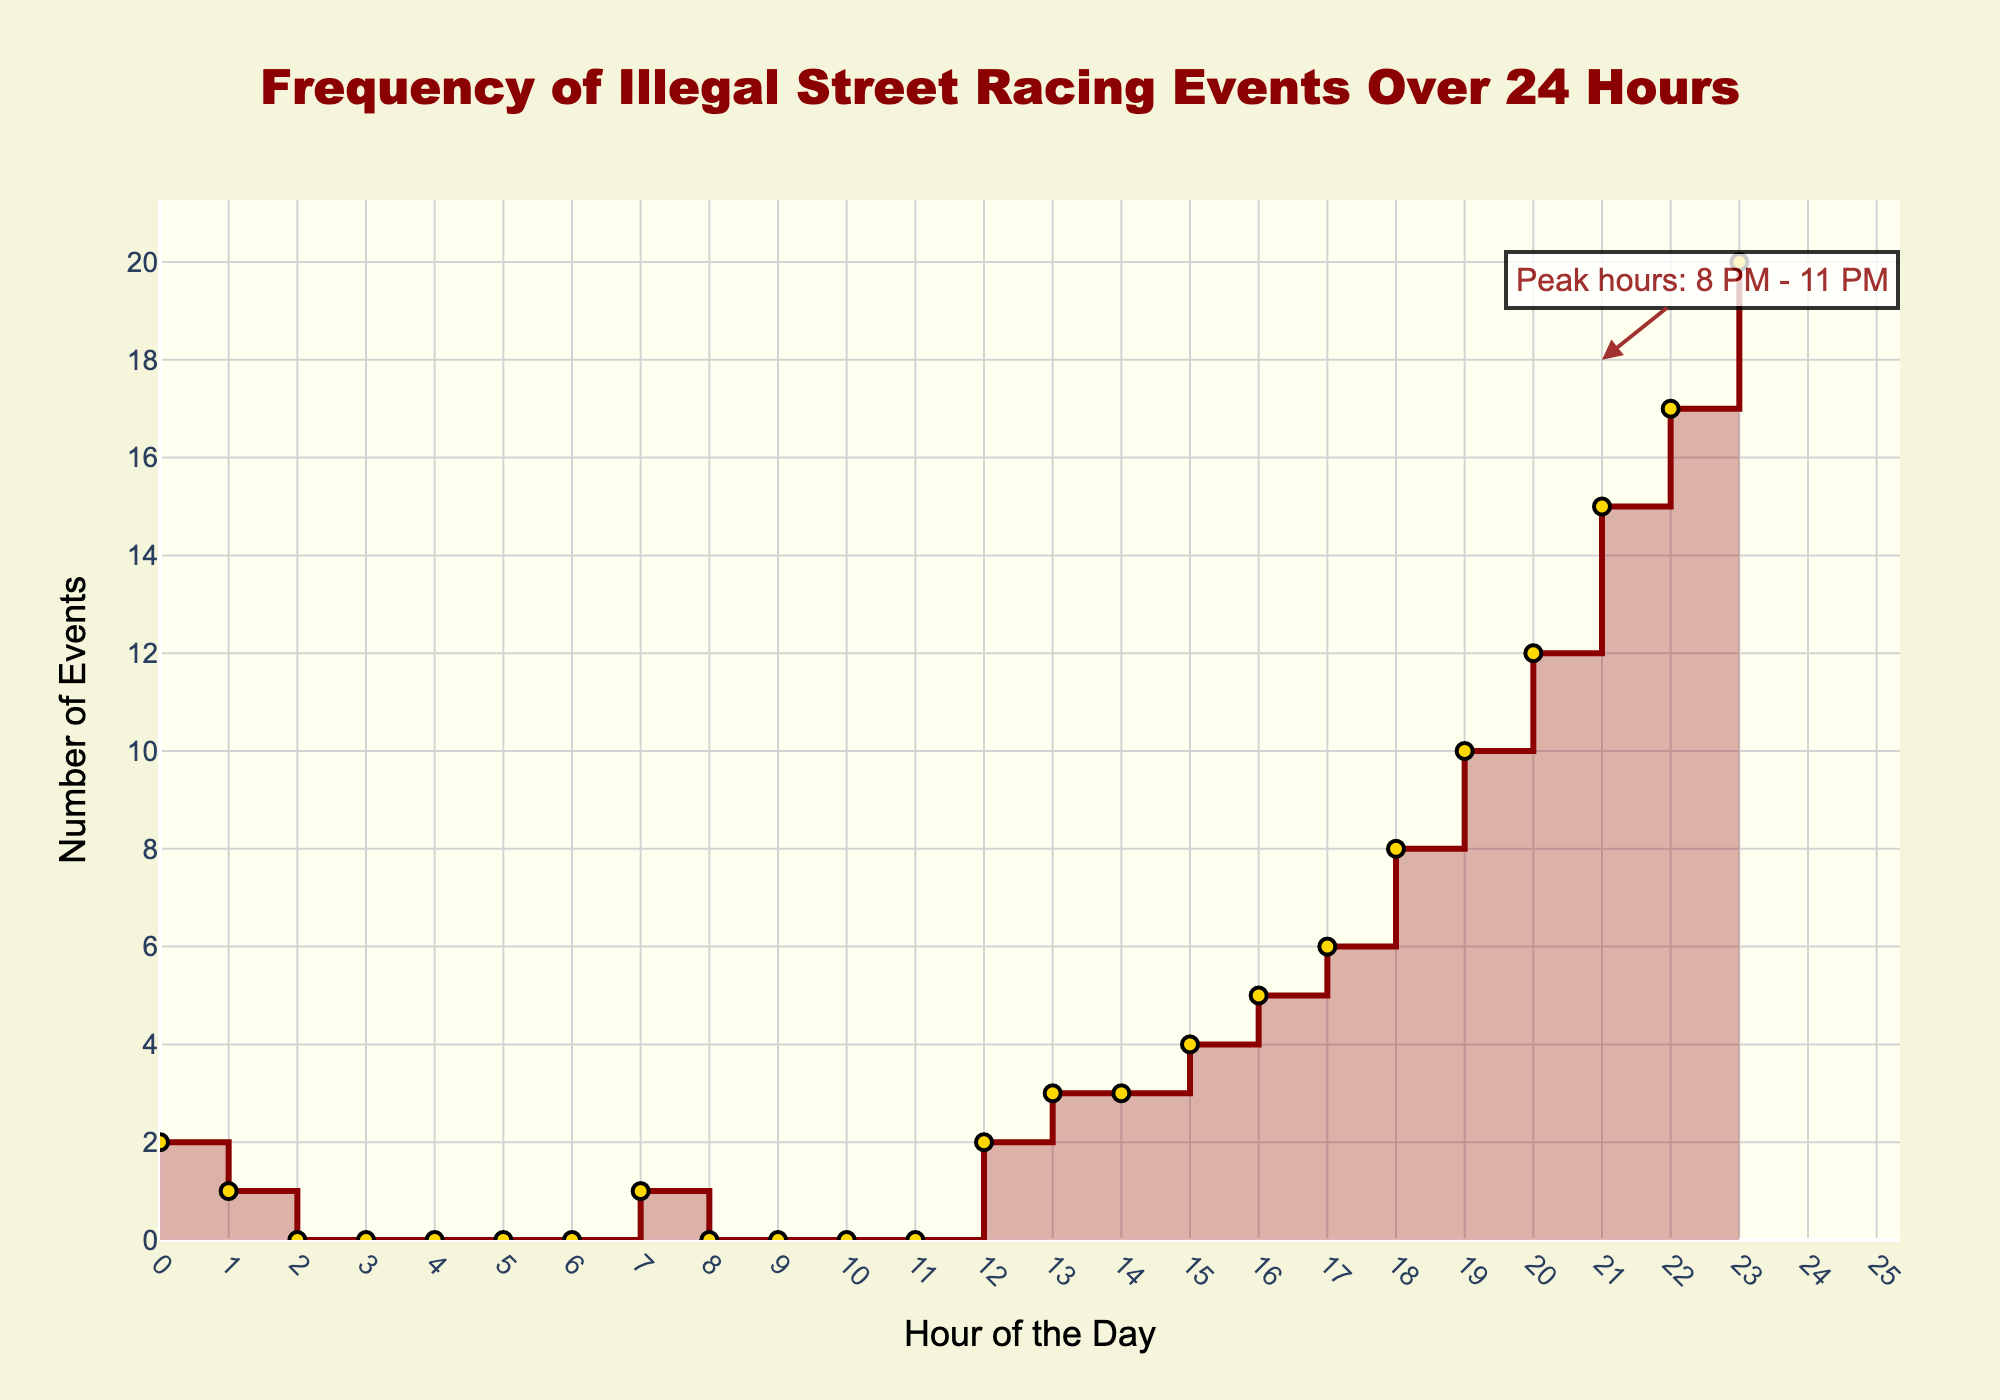What is the title of the plot? The title of the plot is shown at the top of the figure. It reads "Frequency of Illegal Street Racing Events Over 24 Hours."
Answer: Frequency of Illegal Street Racing Events Over 24 Hours How many illegal street racing events happened at 7 AM? By looking at the data points along the y-axis at the 7th hour on the x-axis, we see that the event count is 1.
Answer: 1 What is the total frequency of events between 8 PM and 11 PM? From 8 PM (20th hour) to 11 PM (23rd hour), the event counts are 12, 15, 17, and 20, respectively. Adding these values: 12 + 15 + 17 + 20 = 64.
Answer: 64 During which hours do the highest number of illegal street racing events occur? Observing the y-axis values, the highest frequency is 20 events, which occurs at the 23rd hour (11 PM).
Answer: 23rd hour (11 PM) How does the frequency of events change from 5 PM to 6 PM? The event count at 5 PM (17th hour) is 6, and at 6 PM (18th hour) it is 8. The frequency increases by 2 events.
Answer: Increase by 2 events What is the difference in event count between the peak hour and the start of the day? The peak hour is at 11 PM (23rd hour) with 20 events. At the start of the day (midnight/0 hour), the event count is 2. The difference is 20 - 2 = 18.
Answer: 18 During what hours is there a gradual increase in events from 0 to nearly 20? From examining the stair plot, starting around 12 PM (noon) with 2 events, there is a steady increase up to 23rd hour with 20 events.
Answer: From 12 PM (noon) to 11 PM (23rd hour) What is the pattern observed in the frequency of illegal street racing events during daylight hours as compared to nighttime hours? During daylight (roughly 6 AM to 6 PM) events are lower with a gradual increase starting in the afternoon, while nighttime (6 PM onwards) shows a sharp increase, peaking at 11 PM.
Answer: Lower in the day, sharp increase and peak at night Which hours show no illegal street racing events? Observing the x-axis and corresponding y-axis values, hours with zero event counts are from 2 AM to 6 AM (inclusive).
Answer: 2 AM to 6 AM 